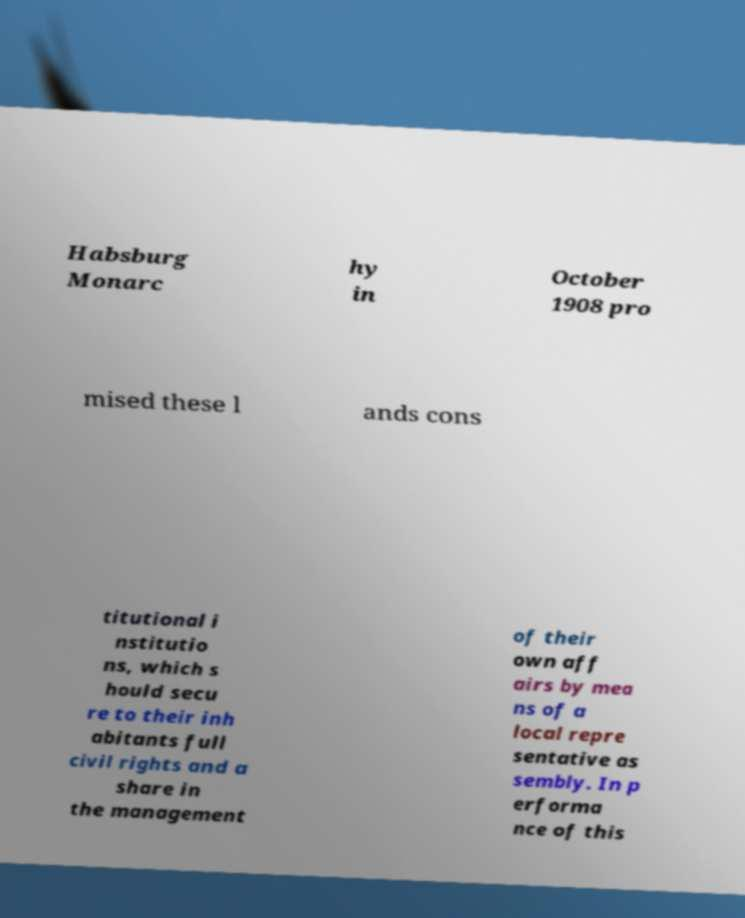Could you extract and type out the text from this image? Habsburg Monarc hy in October 1908 pro mised these l ands cons titutional i nstitutio ns, which s hould secu re to their inh abitants full civil rights and a share in the management of their own aff airs by mea ns of a local repre sentative as sembly. In p erforma nce of this 